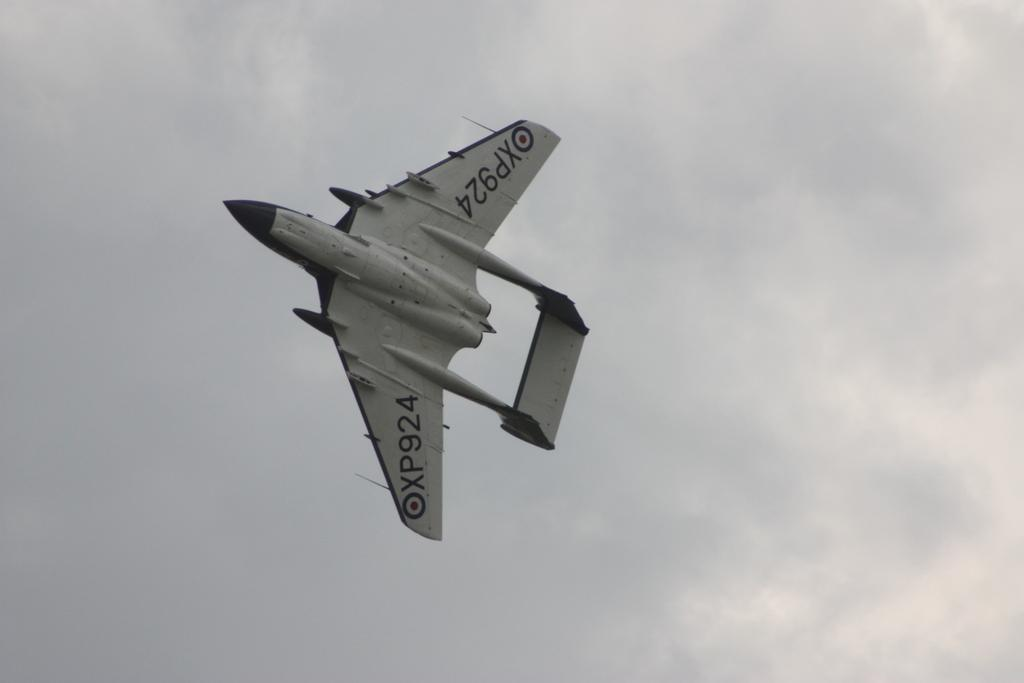<image>
Describe the image concisely. A jet is flying sideways in an overcast sky and has the wing number XP924. 